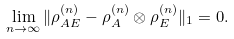Convert formula to latex. <formula><loc_0><loc_0><loc_500><loc_500>\lim _ { n \rightarrow \infty } \| \rho ^ { ( n ) } _ { A E } - \rho ^ { ( n ) } _ { A } \otimes \rho ^ { ( n ) } _ { E } \| _ { 1 } = 0 .</formula> 